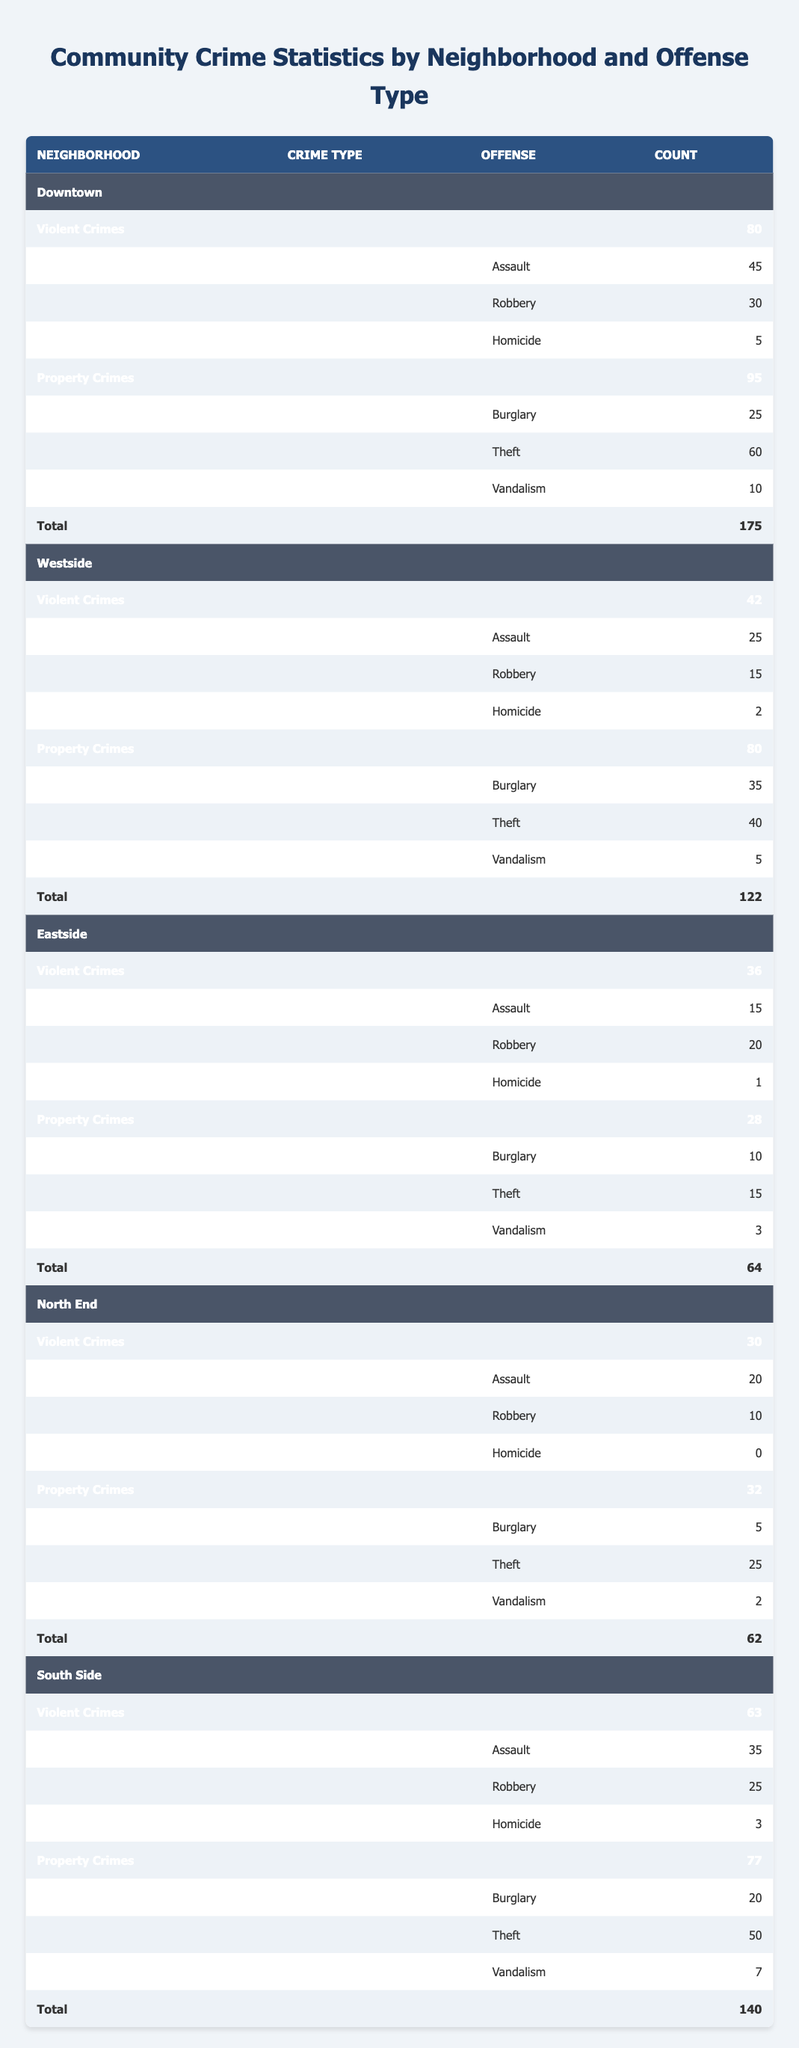What is the total number of violent crimes in Downtown? From the table, the total violent crimes in Downtown consist of Assault (45), Robbery (30), and Homicide (5). Adding these numbers gives: 45 + 30 + 5 = 80.
Answer: 80 Which neighborhood has the highest number of thefts? The table shows that Downtown has the highest number of thefts with a count of 60, compared to 40 in Westside, 15 in Eastside, 25 in North End, and 50 in South Side.
Answer: Downtown Is it true that there were no homicides reported in North End? The table states that the count of homicides in North End is 0, confirming the information.
Answer: Yes What is the average number of burglaries across all neighborhoods? The number of burglaries in each neighborhood is: Downtown (25), Westside (35), Eastside (10), North End (5), and South Side (20). The total is 25 + 35 + 10 + 5 + 20 = 95. To find the average, we divide by the number of neighborhoods: 95 / 5 = 19.
Answer: 19 What is the difference in the total number of property crimes between South Side and Eastside? South Side has a total of 77 property crimes, while Eastside has 28. The difference can be calculated by subtracting the total of Eastside from South Side: 77 - 28 = 49.
Answer: 49 Which neighborhood has the lowest total crime count? The total crime counts are: Downtown (175), Westside (122), Eastside (64), North End (62), and South Side (140). The lowest total is in North End with a count of 62.
Answer: North End How many more violent crimes were reported in South Side than in Westside? The total violent crimes in South Side is 63, and in Westside, it is 42. The difference is calculated as 63 - 42 = 21.
Answer: 21 Is the total number of crimes in Eastside greater than that in North End? The total number of crimes in Eastside is 64, while in North End, it is 62. Comparing these, we find that 64 is greater than 62.
Answer: Yes What is the total count of assaults in the community? The total assaults across all neighborhoods are: Downtown (45), Westside (25), Eastside (15), North End (20), and South Side (35). Adding these gives 45 + 25 + 15 + 20 + 35 = 140.
Answer: 140 